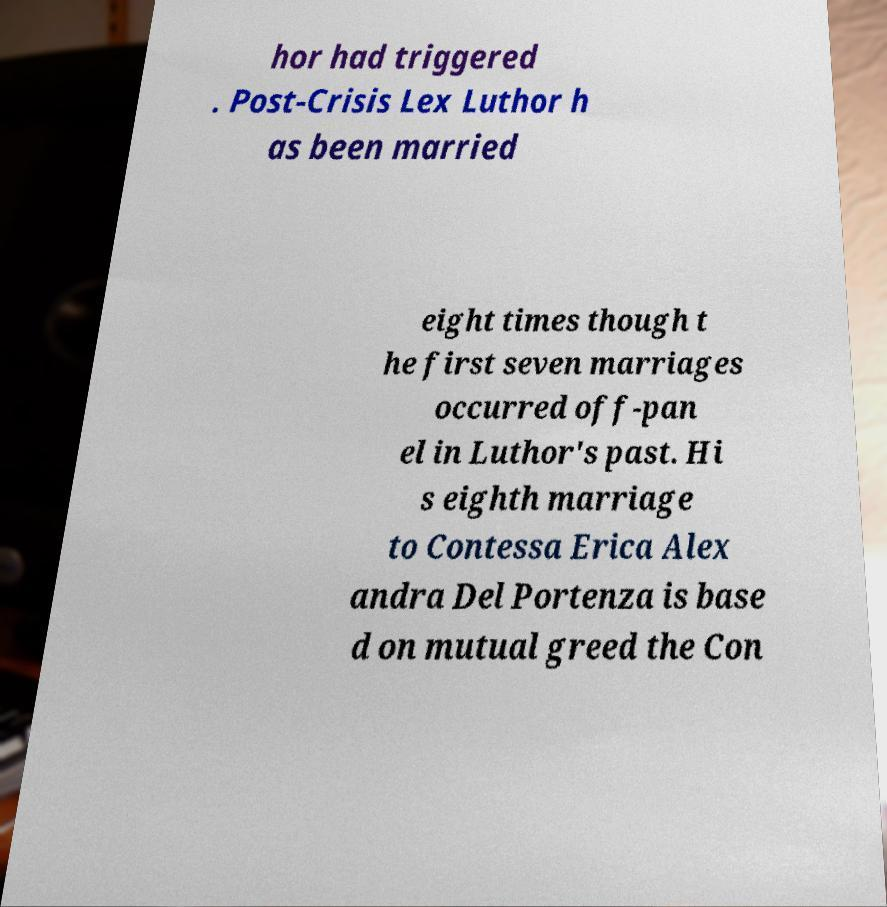There's text embedded in this image that I need extracted. Can you transcribe it verbatim? hor had triggered . Post-Crisis Lex Luthor h as been married eight times though t he first seven marriages occurred off-pan el in Luthor's past. Hi s eighth marriage to Contessa Erica Alex andra Del Portenza is base d on mutual greed the Con 